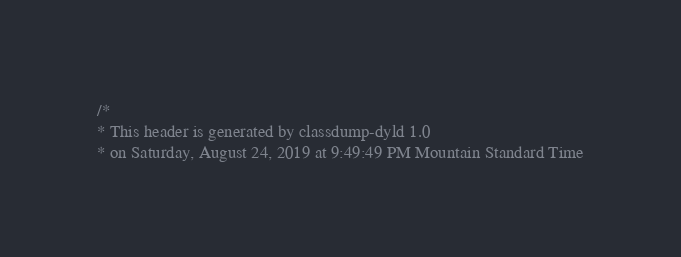Convert code to text. <code><loc_0><loc_0><loc_500><loc_500><_C_>/*
* This header is generated by classdump-dyld 1.0
* on Saturday, August 24, 2019 at 9:49:49 PM Mountain Standard Time</code> 